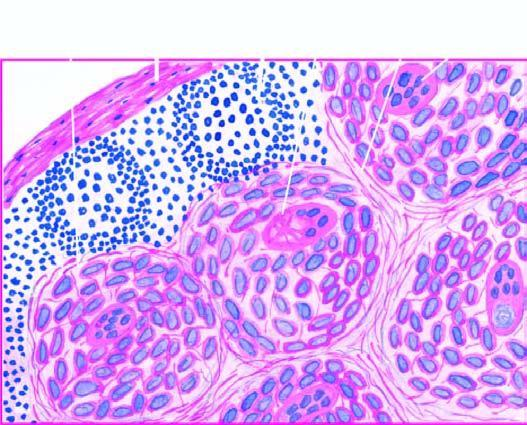what is also seen in the photomicrograph?
Answer the question using a single word or phrase. Giant cell with inclusions 